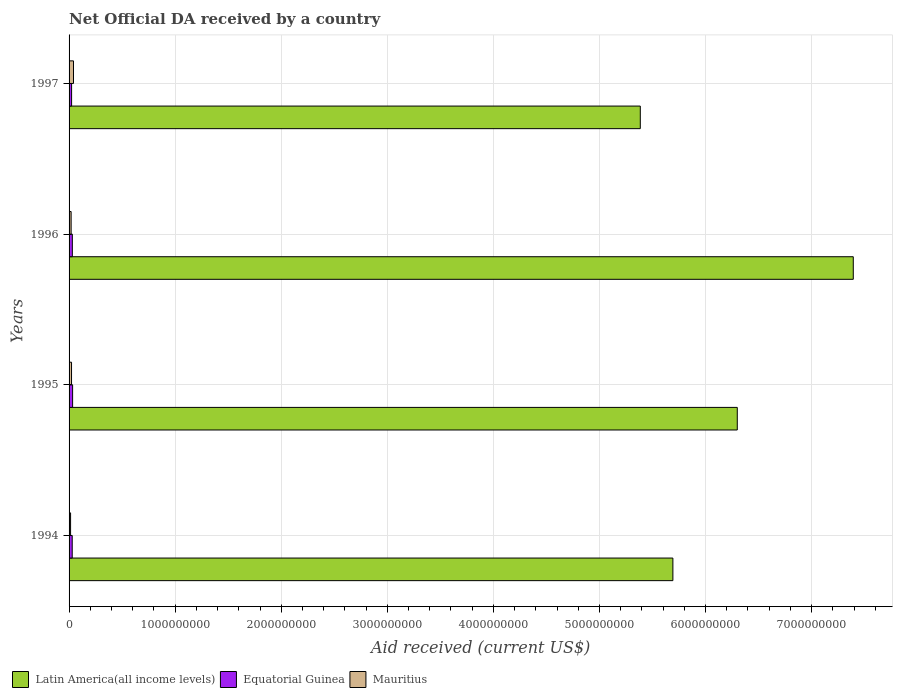How many different coloured bars are there?
Provide a succinct answer. 3. Are the number of bars per tick equal to the number of legend labels?
Your response must be concise. Yes. Are the number of bars on each tick of the Y-axis equal?
Give a very brief answer. Yes. In how many cases, is the number of bars for a given year not equal to the number of legend labels?
Make the answer very short. 0. What is the net official development assistance aid received in Mauritius in 1996?
Provide a succinct answer. 1.94e+07. Across all years, what is the maximum net official development assistance aid received in Mauritius?
Give a very brief answer. 4.17e+07. Across all years, what is the minimum net official development assistance aid received in Mauritius?
Keep it short and to the point. 1.41e+07. In which year was the net official development assistance aid received in Equatorial Guinea minimum?
Provide a short and direct response. 1997. What is the total net official development assistance aid received in Mauritius in the graph?
Make the answer very short. 9.84e+07. What is the difference between the net official development assistance aid received in Equatorial Guinea in 1994 and that in 1995?
Make the answer very short. -3.67e+06. What is the difference between the net official development assistance aid received in Latin America(all income levels) in 1994 and the net official development assistance aid received in Equatorial Guinea in 1995?
Provide a short and direct response. 5.66e+09. What is the average net official development assistance aid received in Mauritius per year?
Your answer should be very brief. 2.46e+07. In the year 1996, what is the difference between the net official development assistance aid received in Mauritius and net official development assistance aid received in Equatorial Guinea?
Ensure brevity in your answer.  -1.14e+07. What is the ratio of the net official development assistance aid received in Equatorial Guinea in 1995 to that in 1996?
Keep it short and to the point. 1.08. What is the difference between the highest and the second highest net official development assistance aid received in Mauritius?
Provide a short and direct response. 1.86e+07. What is the difference between the highest and the lowest net official development assistance aid received in Mauritius?
Your response must be concise. 2.76e+07. In how many years, is the net official development assistance aid received in Mauritius greater than the average net official development assistance aid received in Mauritius taken over all years?
Ensure brevity in your answer.  1. Is the sum of the net official development assistance aid received in Mauritius in 1994 and 1995 greater than the maximum net official development assistance aid received in Latin America(all income levels) across all years?
Your response must be concise. No. What does the 3rd bar from the top in 1996 represents?
Ensure brevity in your answer.  Latin America(all income levels). What does the 2nd bar from the bottom in 1996 represents?
Your answer should be very brief. Equatorial Guinea. Is it the case that in every year, the sum of the net official development assistance aid received in Mauritius and net official development assistance aid received in Latin America(all income levels) is greater than the net official development assistance aid received in Equatorial Guinea?
Ensure brevity in your answer.  Yes. Are all the bars in the graph horizontal?
Provide a succinct answer. Yes. Are the values on the major ticks of X-axis written in scientific E-notation?
Ensure brevity in your answer.  No. Does the graph contain any zero values?
Provide a short and direct response. No. Does the graph contain grids?
Make the answer very short. Yes. How many legend labels are there?
Ensure brevity in your answer.  3. How are the legend labels stacked?
Give a very brief answer. Horizontal. What is the title of the graph?
Provide a short and direct response. Net Official DA received by a country. Does "Australia" appear as one of the legend labels in the graph?
Your answer should be compact. No. What is the label or title of the X-axis?
Offer a terse response. Aid received (current US$). What is the Aid received (current US$) in Latin America(all income levels) in 1994?
Offer a terse response. 5.69e+09. What is the Aid received (current US$) of Equatorial Guinea in 1994?
Ensure brevity in your answer.  2.97e+07. What is the Aid received (current US$) in Mauritius in 1994?
Keep it short and to the point. 1.41e+07. What is the Aid received (current US$) in Latin America(all income levels) in 1995?
Your answer should be compact. 6.30e+09. What is the Aid received (current US$) in Equatorial Guinea in 1995?
Offer a very short reply. 3.34e+07. What is the Aid received (current US$) in Mauritius in 1995?
Give a very brief answer. 2.31e+07. What is the Aid received (current US$) in Latin America(all income levels) in 1996?
Your answer should be very brief. 7.39e+09. What is the Aid received (current US$) of Equatorial Guinea in 1996?
Your answer should be very brief. 3.08e+07. What is the Aid received (current US$) in Mauritius in 1996?
Keep it short and to the point. 1.94e+07. What is the Aid received (current US$) in Latin America(all income levels) in 1997?
Provide a succinct answer. 5.38e+09. What is the Aid received (current US$) of Equatorial Guinea in 1997?
Keep it short and to the point. 2.38e+07. What is the Aid received (current US$) of Mauritius in 1997?
Offer a terse response. 4.17e+07. Across all years, what is the maximum Aid received (current US$) in Latin America(all income levels)?
Your answer should be compact. 7.39e+09. Across all years, what is the maximum Aid received (current US$) of Equatorial Guinea?
Ensure brevity in your answer.  3.34e+07. Across all years, what is the maximum Aid received (current US$) of Mauritius?
Your response must be concise. 4.17e+07. Across all years, what is the minimum Aid received (current US$) in Latin America(all income levels)?
Offer a terse response. 5.38e+09. Across all years, what is the minimum Aid received (current US$) in Equatorial Guinea?
Provide a succinct answer. 2.38e+07. Across all years, what is the minimum Aid received (current US$) in Mauritius?
Give a very brief answer. 1.41e+07. What is the total Aid received (current US$) of Latin America(all income levels) in the graph?
Your answer should be compact. 2.48e+1. What is the total Aid received (current US$) in Equatorial Guinea in the graph?
Your answer should be very brief. 1.18e+08. What is the total Aid received (current US$) in Mauritius in the graph?
Your answer should be compact. 9.84e+07. What is the difference between the Aid received (current US$) of Latin America(all income levels) in 1994 and that in 1995?
Offer a very short reply. -6.07e+08. What is the difference between the Aid received (current US$) of Equatorial Guinea in 1994 and that in 1995?
Give a very brief answer. -3.67e+06. What is the difference between the Aid received (current US$) in Mauritius in 1994 and that in 1995?
Ensure brevity in your answer.  -8.98e+06. What is the difference between the Aid received (current US$) in Latin America(all income levels) in 1994 and that in 1996?
Give a very brief answer. -1.70e+09. What is the difference between the Aid received (current US$) of Equatorial Guinea in 1994 and that in 1996?
Offer a very short reply. -1.09e+06. What is the difference between the Aid received (current US$) of Mauritius in 1994 and that in 1996?
Keep it short and to the point. -5.25e+06. What is the difference between the Aid received (current US$) in Latin America(all income levels) in 1994 and that in 1997?
Ensure brevity in your answer.  3.07e+08. What is the difference between the Aid received (current US$) of Equatorial Guinea in 1994 and that in 1997?
Ensure brevity in your answer.  5.94e+06. What is the difference between the Aid received (current US$) in Mauritius in 1994 and that in 1997?
Your answer should be compact. -2.76e+07. What is the difference between the Aid received (current US$) in Latin America(all income levels) in 1995 and that in 1996?
Keep it short and to the point. -1.09e+09. What is the difference between the Aid received (current US$) of Equatorial Guinea in 1995 and that in 1996?
Keep it short and to the point. 2.58e+06. What is the difference between the Aid received (current US$) in Mauritius in 1995 and that in 1996?
Provide a short and direct response. 3.73e+06. What is the difference between the Aid received (current US$) in Latin America(all income levels) in 1995 and that in 1997?
Give a very brief answer. 9.14e+08. What is the difference between the Aid received (current US$) of Equatorial Guinea in 1995 and that in 1997?
Provide a succinct answer. 9.61e+06. What is the difference between the Aid received (current US$) of Mauritius in 1995 and that in 1997?
Your answer should be compact. -1.86e+07. What is the difference between the Aid received (current US$) in Latin America(all income levels) in 1996 and that in 1997?
Provide a short and direct response. 2.01e+09. What is the difference between the Aid received (current US$) of Equatorial Guinea in 1996 and that in 1997?
Give a very brief answer. 7.03e+06. What is the difference between the Aid received (current US$) of Mauritius in 1996 and that in 1997?
Your answer should be compact. -2.23e+07. What is the difference between the Aid received (current US$) in Latin America(all income levels) in 1994 and the Aid received (current US$) in Equatorial Guinea in 1995?
Offer a very short reply. 5.66e+09. What is the difference between the Aid received (current US$) of Latin America(all income levels) in 1994 and the Aid received (current US$) of Mauritius in 1995?
Your answer should be very brief. 5.67e+09. What is the difference between the Aid received (current US$) in Equatorial Guinea in 1994 and the Aid received (current US$) in Mauritius in 1995?
Keep it short and to the point. 6.61e+06. What is the difference between the Aid received (current US$) in Latin America(all income levels) in 1994 and the Aid received (current US$) in Equatorial Guinea in 1996?
Offer a terse response. 5.66e+09. What is the difference between the Aid received (current US$) in Latin America(all income levels) in 1994 and the Aid received (current US$) in Mauritius in 1996?
Offer a terse response. 5.67e+09. What is the difference between the Aid received (current US$) in Equatorial Guinea in 1994 and the Aid received (current US$) in Mauritius in 1996?
Offer a very short reply. 1.03e+07. What is the difference between the Aid received (current US$) in Latin America(all income levels) in 1994 and the Aid received (current US$) in Equatorial Guinea in 1997?
Keep it short and to the point. 5.67e+09. What is the difference between the Aid received (current US$) in Latin America(all income levels) in 1994 and the Aid received (current US$) in Mauritius in 1997?
Give a very brief answer. 5.65e+09. What is the difference between the Aid received (current US$) of Equatorial Guinea in 1994 and the Aid received (current US$) of Mauritius in 1997?
Provide a short and direct response. -1.20e+07. What is the difference between the Aid received (current US$) of Latin America(all income levels) in 1995 and the Aid received (current US$) of Equatorial Guinea in 1996?
Ensure brevity in your answer.  6.27e+09. What is the difference between the Aid received (current US$) of Latin America(all income levels) in 1995 and the Aid received (current US$) of Mauritius in 1996?
Your answer should be very brief. 6.28e+09. What is the difference between the Aid received (current US$) of Equatorial Guinea in 1995 and the Aid received (current US$) of Mauritius in 1996?
Ensure brevity in your answer.  1.40e+07. What is the difference between the Aid received (current US$) of Latin America(all income levels) in 1995 and the Aid received (current US$) of Equatorial Guinea in 1997?
Ensure brevity in your answer.  6.28e+09. What is the difference between the Aid received (current US$) of Latin America(all income levels) in 1995 and the Aid received (current US$) of Mauritius in 1997?
Your answer should be compact. 6.26e+09. What is the difference between the Aid received (current US$) of Equatorial Guinea in 1995 and the Aid received (current US$) of Mauritius in 1997?
Your answer should be compact. -8.30e+06. What is the difference between the Aid received (current US$) in Latin America(all income levels) in 1996 and the Aid received (current US$) in Equatorial Guinea in 1997?
Ensure brevity in your answer.  7.37e+09. What is the difference between the Aid received (current US$) of Latin America(all income levels) in 1996 and the Aid received (current US$) of Mauritius in 1997?
Provide a short and direct response. 7.35e+09. What is the difference between the Aid received (current US$) of Equatorial Guinea in 1996 and the Aid received (current US$) of Mauritius in 1997?
Your answer should be compact. -1.09e+07. What is the average Aid received (current US$) in Latin America(all income levels) per year?
Provide a succinct answer. 6.19e+09. What is the average Aid received (current US$) of Equatorial Guinea per year?
Provide a succinct answer. 2.94e+07. What is the average Aid received (current US$) in Mauritius per year?
Provide a succinct answer. 2.46e+07. In the year 1994, what is the difference between the Aid received (current US$) of Latin America(all income levels) and Aid received (current US$) of Equatorial Guinea?
Your response must be concise. 5.66e+09. In the year 1994, what is the difference between the Aid received (current US$) in Latin America(all income levels) and Aid received (current US$) in Mauritius?
Give a very brief answer. 5.68e+09. In the year 1994, what is the difference between the Aid received (current US$) in Equatorial Guinea and Aid received (current US$) in Mauritius?
Your response must be concise. 1.56e+07. In the year 1995, what is the difference between the Aid received (current US$) of Latin America(all income levels) and Aid received (current US$) of Equatorial Guinea?
Offer a very short reply. 6.27e+09. In the year 1995, what is the difference between the Aid received (current US$) in Latin America(all income levels) and Aid received (current US$) in Mauritius?
Provide a succinct answer. 6.28e+09. In the year 1995, what is the difference between the Aid received (current US$) in Equatorial Guinea and Aid received (current US$) in Mauritius?
Offer a terse response. 1.03e+07. In the year 1996, what is the difference between the Aid received (current US$) in Latin America(all income levels) and Aid received (current US$) in Equatorial Guinea?
Keep it short and to the point. 7.36e+09. In the year 1996, what is the difference between the Aid received (current US$) in Latin America(all income levels) and Aid received (current US$) in Mauritius?
Your response must be concise. 7.37e+09. In the year 1996, what is the difference between the Aid received (current US$) of Equatorial Guinea and Aid received (current US$) of Mauritius?
Provide a succinct answer. 1.14e+07. In the year 1997, what is the difference between the Aid received (current US$) in Latin America(all income levels) and Aid received (current US$) in Equatorial Guinea?
Ensure brevity in your answer.  5.36e+09. In the year 1997, what is the difference between the Aid received (current US$) of Latin America(all income levels) and Aid received (current US$) of Mauritius?
Make the answer very short. 5.34e+09. In the year 1997, what is the difference between the Aid received (current US$) in Equatorial Guinea and Aid received (current US$) in Mauritius?
Make the answer very short. -1.79e+07. What is the ratio of the Aid received (current US$) of Latin America(all income levels) in 1994 to that in 1995?
Provide a short and direct response. 0.9. What is the ratio of the Aid received (current US$) of Equatorial Guinea in 1994 to that in 1995?
Your response must be concise. 0.89. What is the ratio of the Aid received (current US$) of Mauritius in 1994 to that in 1995?
Offer a very short reply. 0.61. What is the ratio of the Aid received (current US$) in Latin America(all income levels) in 1994 to that in 1996?
Your answer should be very brief. 0.77. What is the ratio of the Aid received (current US$) of Equatorial Guinea in 1994 to that in 1996?
Offer a terse response. 0.96. What is the ratio of the Aid received (current US$) of Mauritius in 1994 to that in 1996?
Make the answer very short. 0.73. What is the ratio of the Aid received (current US$) in Latin America(all income levels) in 1994 to that in 1997?
Provide a succinct answer. 1.06. What is the ratio of the Aid received (current US$) of Equatorial Guinea in 1994 to that in 1997?
Offer a very short reply. 1.25. What is the ratio of the Aid received (current US$) in Mauritius in 1994 to that in 1997?
Your response must be concise. 0.34. What is the ratio of the Aid received (current US$) in Latin America(all income levels) in 1995 to that in 1996?
Offer a very short reply. 0.85. What is the ratio of the Aid received (current US$) of Equatorial Guinea in 1995 to that in 1996?
Ensure brevity in your answer.  1.08. What is the ratio of the Aid received (current US$) in Mauritius in 1995 to that in 1996?
Keep it short and to the point. 1.19. What is the ratio of the Aid received (current US$) in Latin America(all income levels) in 1995 to that in 1997?
Your response must be concise. 1.17. What is the ratio of the Aid received (current US$) in Equatorial Guinea in 1995 to that in 1997?
Offer a terse response. 1.4. What is the ratio of the Aid received (current US$) of Mauritius in 1995 to that in 1997?
Your response must be concise. 0.55. What is the ratio of the Aid received (current US$) of Latin America(all income levels) in 1996 to that in 1997?
Offer a terse response. 1.37. What is the ratio of the Aid received (current US$) of Equatorial Guinea in 1996 to that in 1997?
Offer a terse response. 1.3. What is the ratio of the Aid received (current US$) of Mauritius in 1996 to that in 1997?
Your response must be concise. 0.47. What is the difference between the highest and the second highest Aid received (current US$) of Latin America(all income levels)?
Give a very brief answer. 1.09e+09. What is the difference between the highest and the second highest Aid received (current US$) of Equatorial Guinea?
Offer a terse response. 2.58e+06. What is the difference between the highest and the second highest Aid received (current US$) of Mauritius?
Your answer should be compact. 1.86e+07. What is the difference between the highest and the lowest Aid received (current US$) in Latin America(all income levels)?
Your answer should be very brief. 2.01e+09. What is the difference between the highest and the lowest Aid received (current US$) of Equatorial Guinea?
Your answer should be compact. 9.61e+06. What is the difference between the highest and the lowest Aid received (current US$) of Mauritius?
Ensure brevity in your answer.  2.76e+07. 